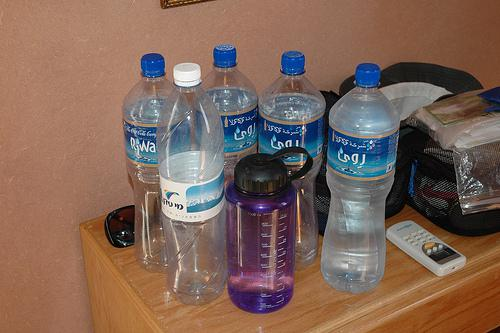Question: what color is the nightstand?
Choices:
A. The nightstand is tan.
B. It's blue.
C. The nightstand is black.
D. White.
Answer with the letter. Answer: A Question: how many bottles are on the table?
Choices:
A. 6 bottles on the table.
B. 3 bottles on the table.
C. 4 bottles on the table.
D. 5 bottles on the table.
Answer with the letter. Answer: A Question: where are the sunglasses?
Choices:
A. On her head.
B. On the table.
C. In the chair.
D. Behind the water bottle.
Answer with the letter. Answer: D Question: what color is the shortest bottle?
Choices:
A. The shortest is blue.
B. The shortest bottle is purple.
C. The shortest bottle is red.
D. Yellow.
Answer with the letter. Answer: B Question: where is the remote?
Choices:
A. On the floor.
B. In the boys hand.
C. On the table.
D. On the couch.
Answer with the letter. Answer: C Question: what color are the bottle tops?
Choices:
A. The bottle tops are blue and white.
B. The bottle tops are red and black.
C. The bottle tops are red and white.
D. The bottle tops are green and white.
Answer with the letter. Answer: A 